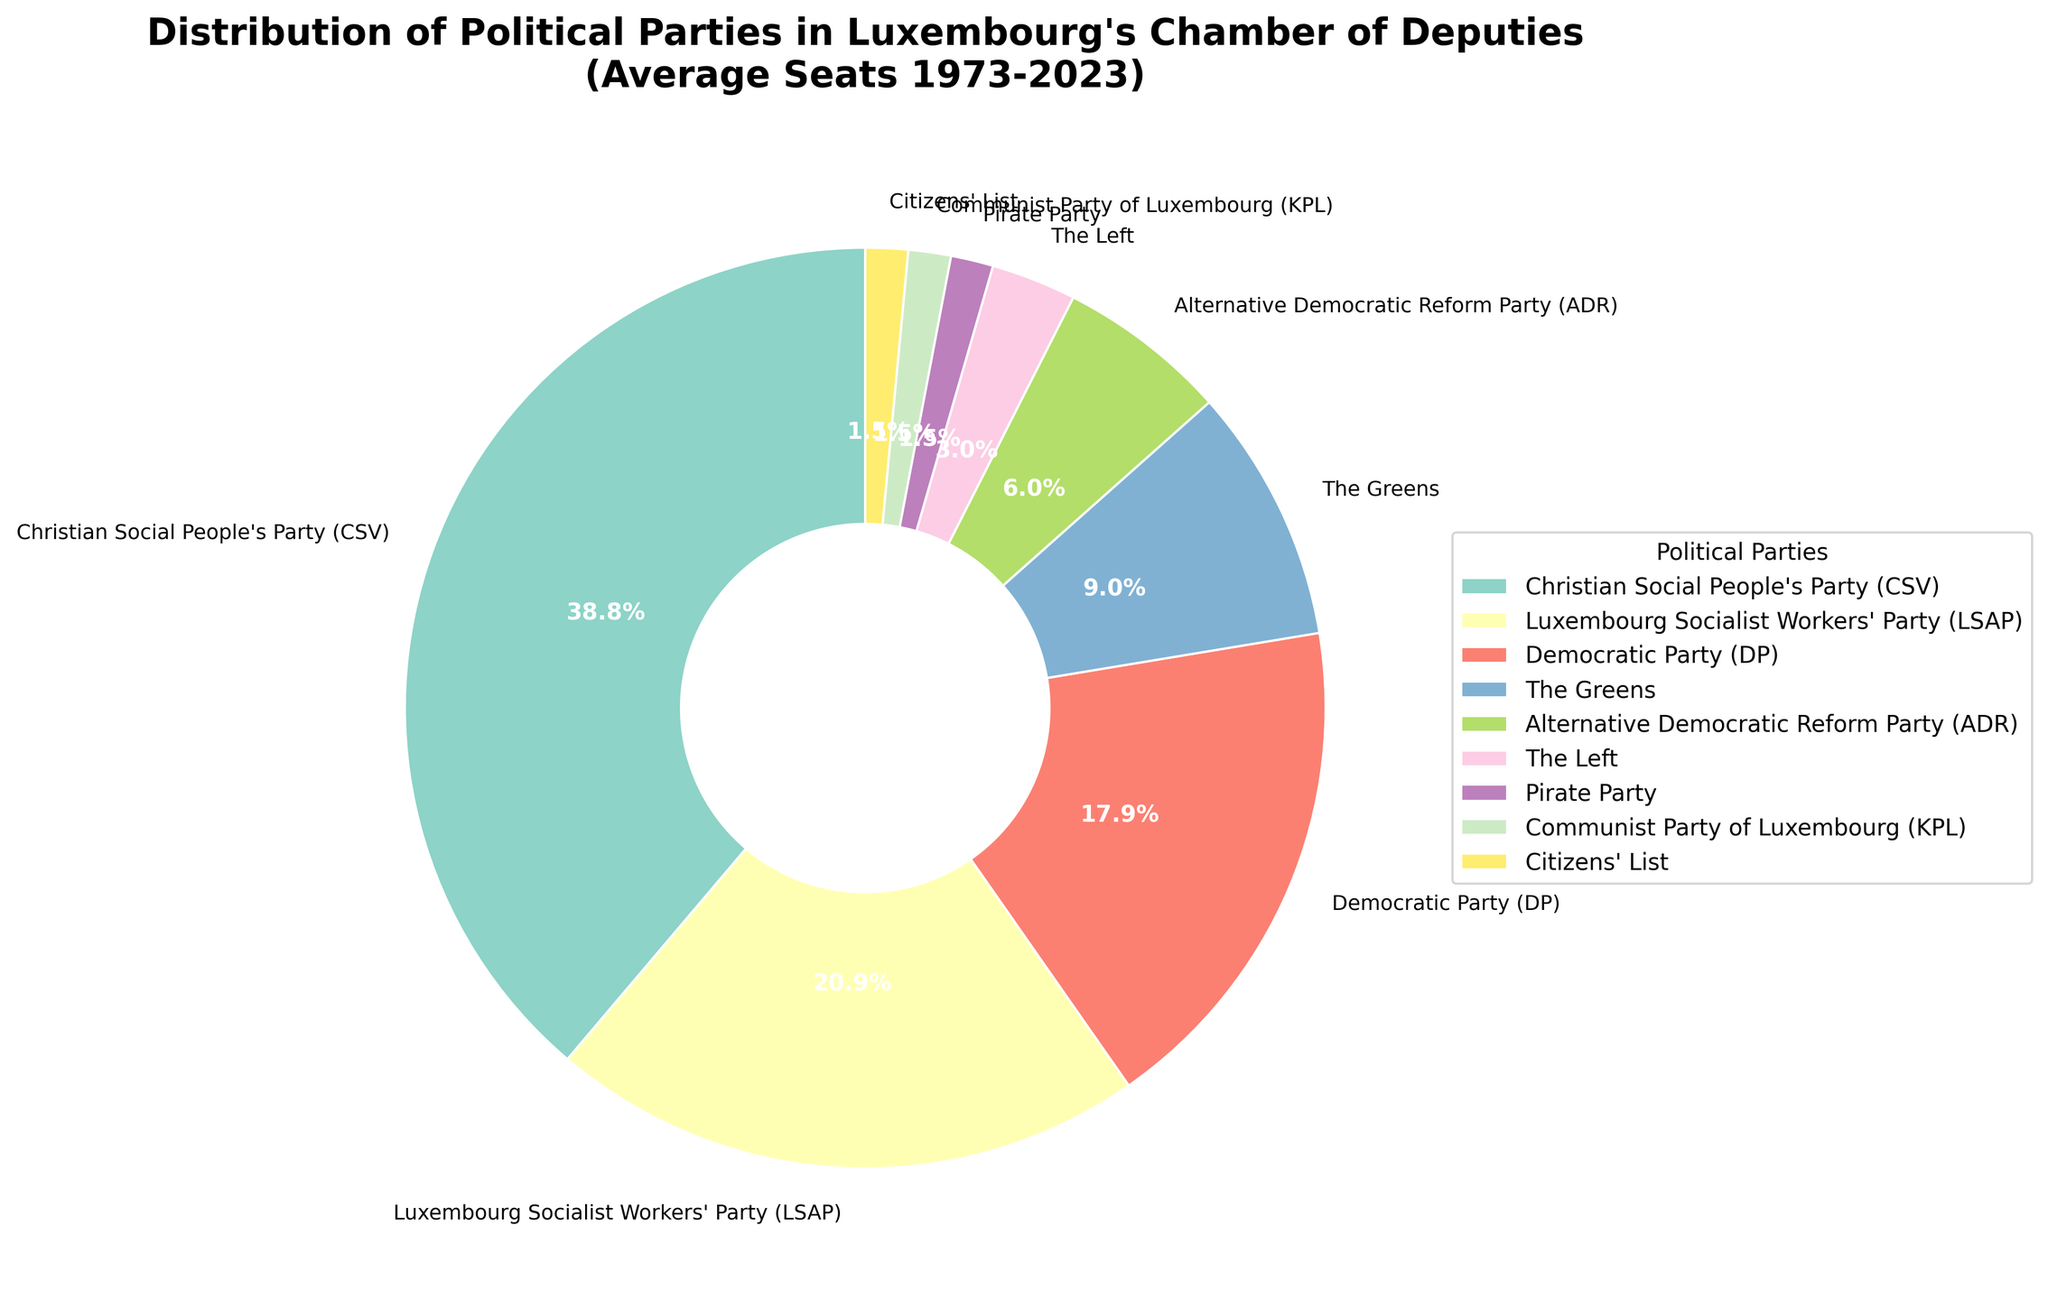Which political party holds the highest average number of seats? According to the pie chart, we observe that the Christian Social People's Party (CSV) has the largest wedge, indicating that it holds the highest average number of seats.
Answer: Christian Social People's Party (CSV) Which two parties combined hold fewer average seats than The Greens? The Greens have an average of 6 seats. By observing the chart, we can see that The Left, Pirate Party, Communist Party of Luxembourg (KPL), and Citizens' List each hold 2, 1, 1, and 1 seats respectively. The sum of any pair of these parties is less than 6.
Answer: Any two of The Left, Pirate Party, KPL, and Citizens' List Which party has a greater average number of seats: Democratic Party (DP) or Luxembourg Socialist Workers' Party (LSAP)? Observing the pie chart, we can see that the wedge representing the LSAP is larger than the DP. LSAP has 14 seats on average, while DP has 12.
Answer: Luxembourg Socialist Workers' Party (LSAP) What percentage of the total seats is held by the Alternative Democratic Reform Party (ADR)? The ADR has 4 seats. To find the percentage, we need to calculate (4/total seats) * 100. Summing up the average seats of all parties: 26+14+12+6+4+2+1+1+1 = 67. Thus, (4/67) * 100 ≈ 5.97%.
Answer: Approximately 6% How many more average seats does the Christian Social People's Party (CSV) have compared to its nearest competitor? The CSV has 26 seats on average, and the nearest competitor, LSAP, has 14 seats. The difference is 26 - 14 = 12 seats.
Answer: 12 seats Which parties hold the smallest average number of seats, and how many do they hold? From the pie chart, the Communist Party of Luxembourg (KPL) and Citizens' List each hold 1 seat.
Answer: KPL and Citizens' List, 1 seat each What is the combined percentage of the total seats for the parties holding the top three average seat counts? The top three parties by seat count are CSV (26), LSAP (14), and DP (12). Total seats: 26+14+12 = 52. To get the percentage: (52/67) * 100 ≈ 77.6%.
Answer: Approximately 77.6% Which party has slightly more average seats, ADR or The Greens, and by how many? Observing the chart, The Greens have 6 seats while ADR has 4 seats on average. The difference is 6 - 4 = 2 seats.
Answer: The Greens, 2 seats What is the average number of seats occupied by the bottom four parties? The bottom four parties are The Left (2), Pirate Party (1), KPL (1), and Citizens' List (1). Their total seats sum up to (2+1+1+1) = 5. The average is 5/4 = 1.25 seats.
Answer: 1.25 seats Of the parties listed, which color represents The Greens in the pie chart, and how can you identify it? In the pie chart, The Greens are typically represented by a color resembling green. By comparing the wedge colors, we can identify the corresponding party based on this visual trait.
Answer: A shade of green 